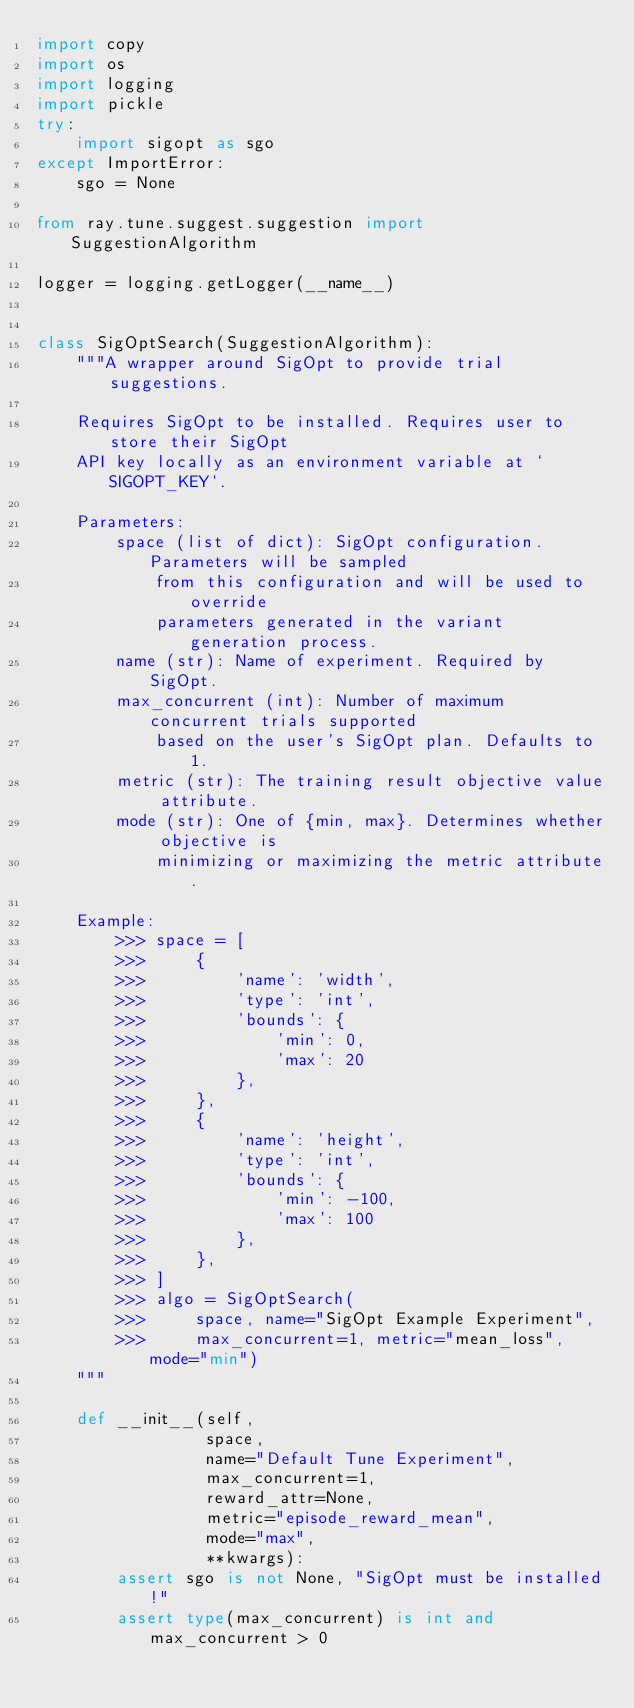Convert code to text. <code><loc_0><loc_0><loc_500><loc_500><_Python_>import copy
import os
import logging
import pickle
try:
    import sigopt as sgo
except ImportError:
    sgo = None

from ray.tune.suggest.suggestion import SuggestionAlgorithm

logger = logging.getLogger(__name__)


class SigOptSearch(SuggestionAlgorithm):
    """A wrapper around SigOpt to provide trial suggestions.

    Requires SigOpt to be installed. Requires user to store their SigOpt
    API key locally as an environment variable at `SIGOPT_KEY`.

    Parameters:
        space (list of dict): SigOpt configuration. Parameters will be sampled
            from this configuration and will be used to override
            parameters generated in the variant generation process.
        name (str): Name of experiment. Required by SigOpt.
        max_concurrent (int): Number of maximum concurrent trials supported
            based on the user's SigOpt plan. Defaults to 1.
        metric (str): The training result objective value attribute.
        mode (str): One of {min, max}. Determines whether objective is
            minimizing or maximizing the metric attribute.

    Example:
        >>> space = [
        >>>     {
        >>>         'name': 'width',
        >>>         'type': 'int',
        >>>         'bounds': {
        >>>             'min': 0,
        >>>             'max': 20
        >>>         },
        >>>     },
        >>>     {
        >>>         'name': 'height',
        >>>         'type': 'int',
        >>>         'bounds': {
        >>>             'min': -100,
        >>>             'max': 100
        >>>         },
        >>>     },
        >>> ]
        >>> algo = SigOptSearch(
        >>>     space, name="SigOpt Example Experiment",
        >>>     max_concurrent=1, metric="mean_loss", mode="min")
    """

    def __init__(self,
                 space,
                 name="Default Tune Experiment",
                 max_concurrent=1,
                 reward_attr=None,
                 metric="episode_reward_mean",
                 mode="max",
                 **kwargs):
        assert sgo is not None, "SigOpt must be installed!"
        assert type(max_concurrent) is int and max_concurrent > 0</code> 